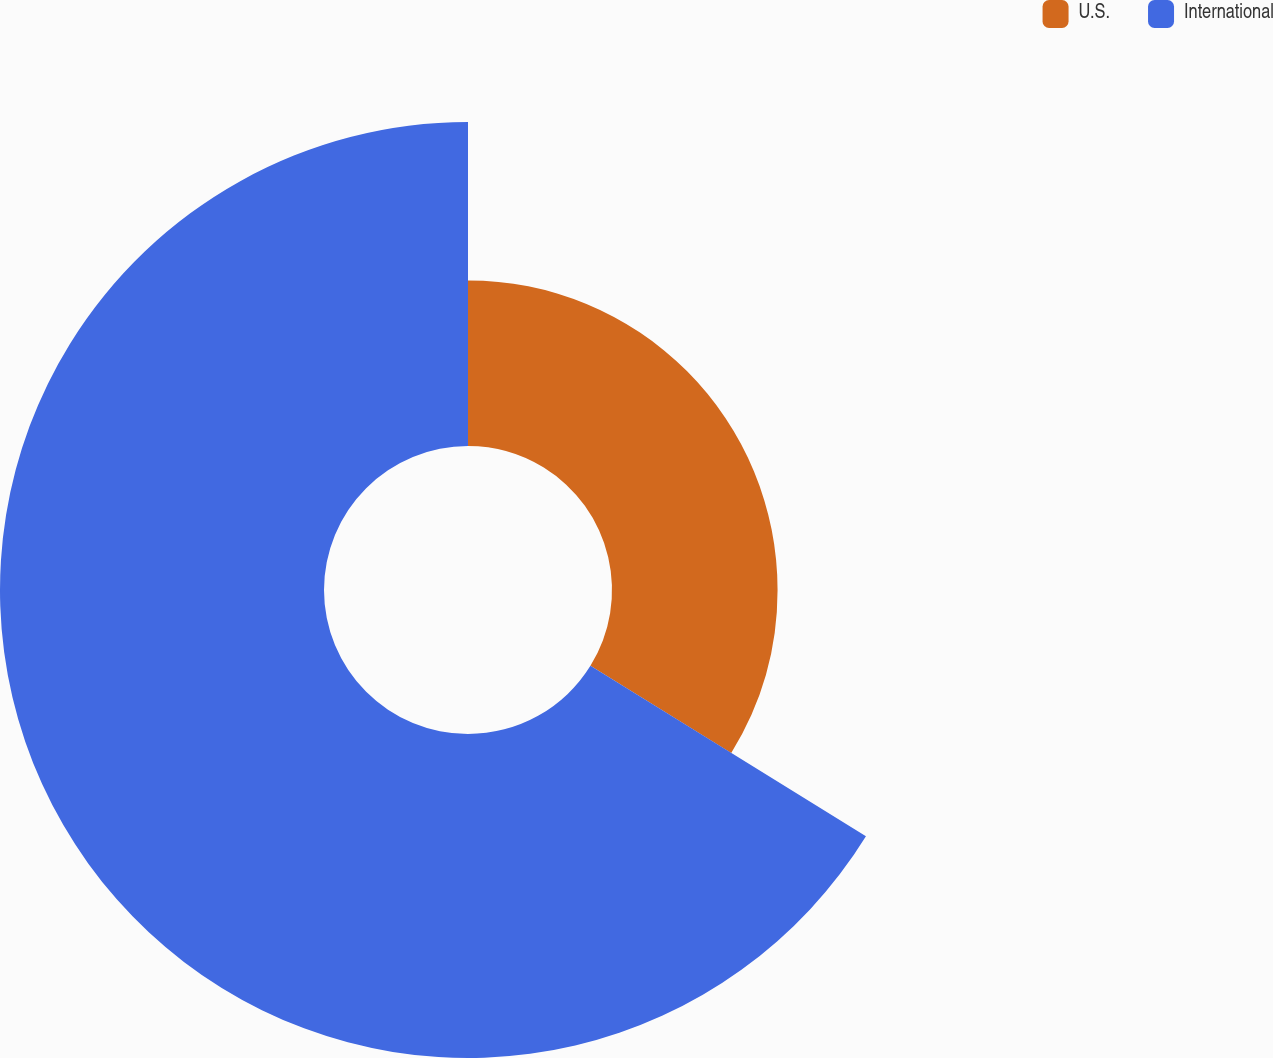Convert chart to OTSL. <chart><loc_0><loc_0><loc_500><loc_500><pie_chart><fcel>U.S.<fcel>International<nl><fcel>33.82%<fcel>66.18%<nl></chart> 